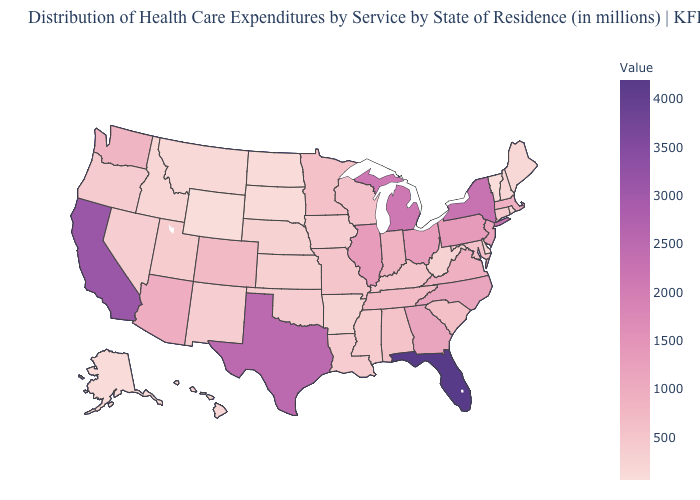Which states have the lowest value in the South?
Short answer required. Delaware. Among the states that border Arizona , does California have the highest value?
Quick response, please. Yes. Does Arkansas have the lowest value in the South?
Concise answer only. No. Among the states that border Missouri , does Tennessee have the highest value?
Short answer required. No. 